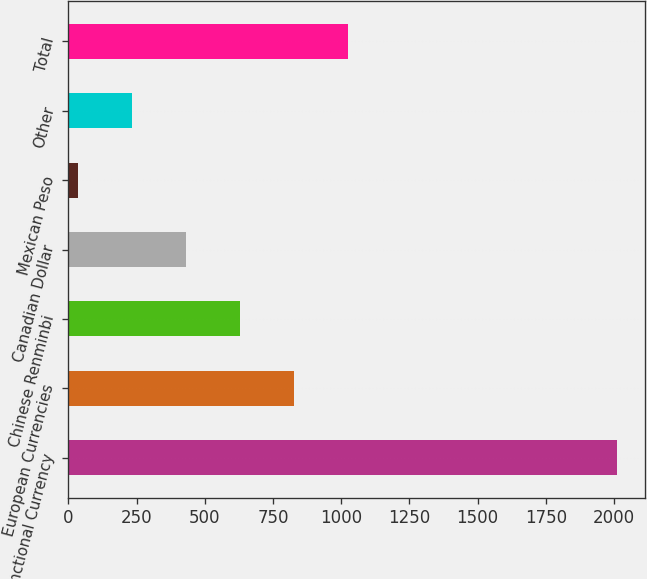Convert chart to OTSL. <chart><loc_0><loc_0><loc_500><loc_500><bar_chart><fcel>Functional Currency<fcel>European Currencies<fcel>Chinese Renminbi<fcel>Canadian Dollar<fcel>Mexican Peso<fcel>Other<fcel>Total<nl><fcel>2013<fcel>825.96<fcel>628.12<fcel>430.28<fcel>34.6<fcel>232.44<fcel>1023.8<nl></chart> 